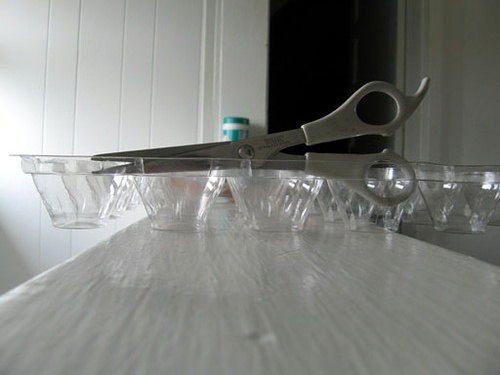Describe the objects in this image and their specific colors. I can see scissors in lightgray, black, gray, and darkgray tones in this image. 